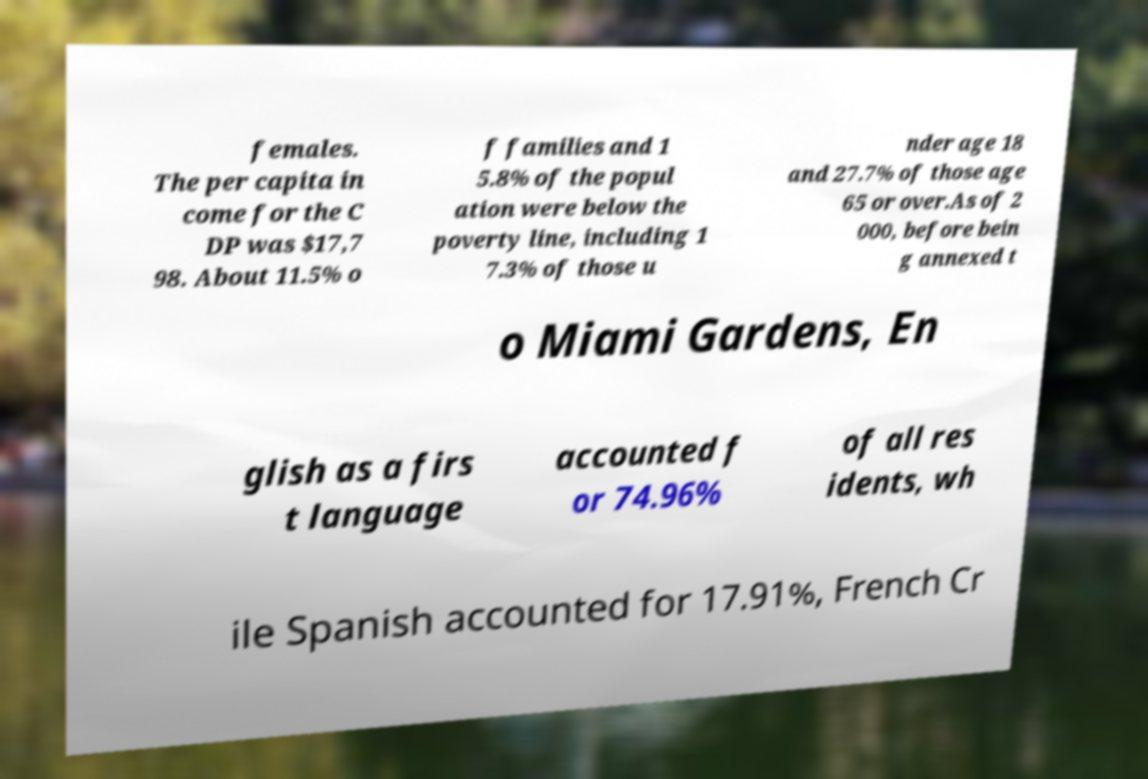There's text embedded in this image that I need extracted. Can you transcribe it verbatim? females. The per capita in come for the C DP was $17,7 98. About 11.5% o f families and 1 5.8% of the popul ation were below the poverty line, including 1 7.3% of those u nder age 18 and 27.7% of those age 65 or over.As of 2 000, before bein g annexed t o Miami Gardens, En glish as a firs t language accounted f or 74.96% of all res idents, wh ile Spanish accounted for 17.91%, French Cr 